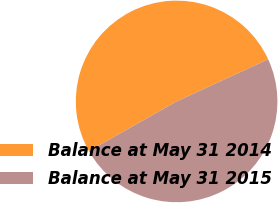<chart> <loc_0><loc_0><loc_500><loc_500><pie_chart><fcel>Balance at May 31 2014<fcel>Balance at May 31 2015<nl><fcel>51.33%<fcel>48.67%<nl></chart> 